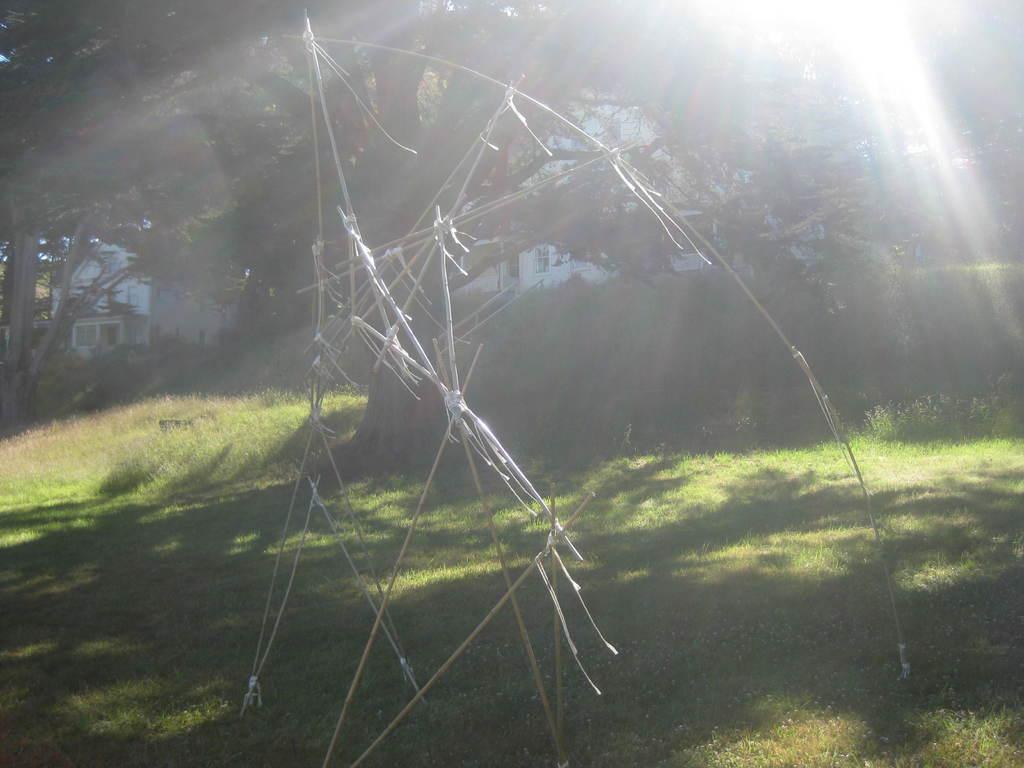How would you summarize this image in a sentence or two? Here I can see some sticks. In the background there are some trees and buildings. At the bottom, I can see the grass on the ground. At the top of the image there is a light. 